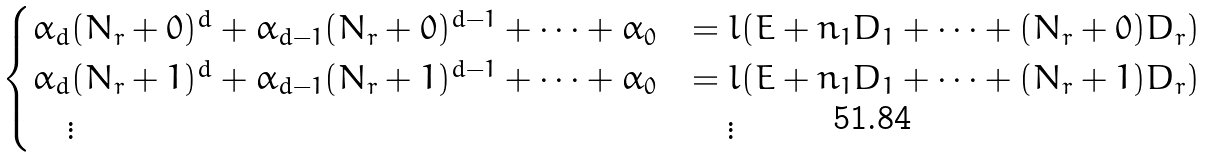Convert formula to latex. <formula><loc_0><loc_0><loc_500><loc_500>\begin{cases} \alpha _ { d } ( N _ { r } + 0 ) ^ { d } + \alpha _ { d - 1 } ( N _ { r } + 0 ) ^ { d - 1 } + \cdots + \alpha _ { 0 } & = l ( E + n _ { 1 } D _ { 1 } + \cdots + ( N _ { r } + 0 ) D _ { r } ) \\ \alpha _ { d } ( N _ { r } + 1 ) ^ { d } + \alpha _ { d - 1 } ( N _ { r } + 1 ) ^ { d - 1 } + \cdots + \alpha _ { 0 } & = l ( E + n _ { 1 } D _ { 1 } + \cdots + ( N _ { r } + 1 ) D _ { r } ) \\ \quad \vdots & \quad \vdots \\ \end{cases}</formula> 